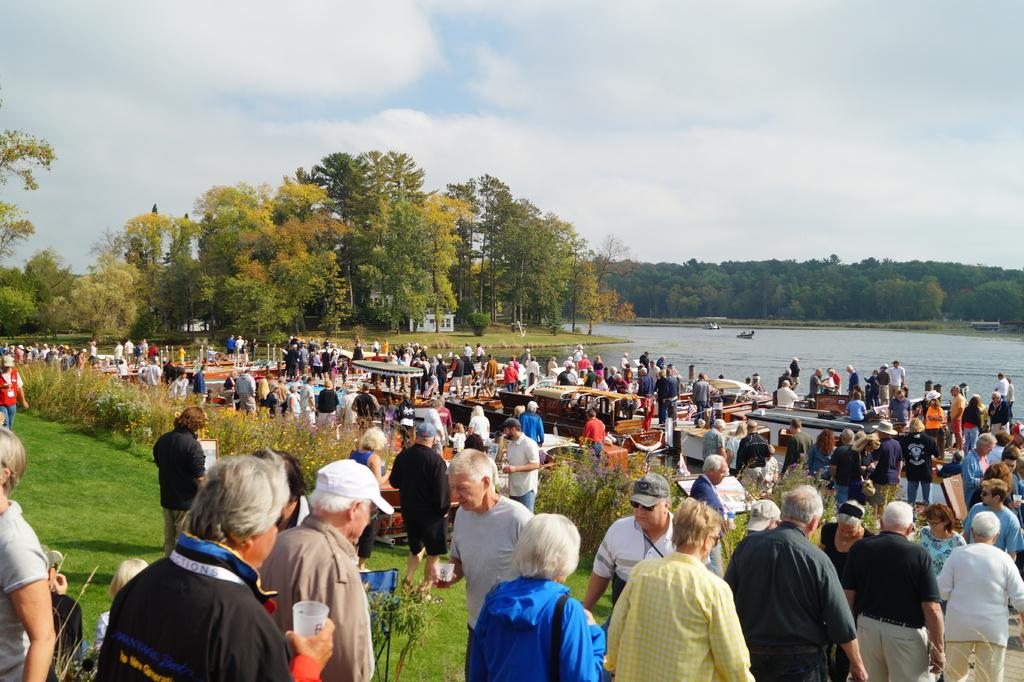What can be seen in the image? There are people, boats, water, grass, plants, boards, houses, trees, and various objects in the image. What is the setting of the image? The image appears to be set near a body of water, with houses, trees, and grass visible. What is the weather like in the image? The sky is visible in the background of the image, with clouds present, suggesting a partly cloudy day. What can be seen in the sky? There are clouds in the sky in the image. What type of apparel is the camera wearing in the image? There is no camera present in the image, so it cannot be wearing any apparel. 